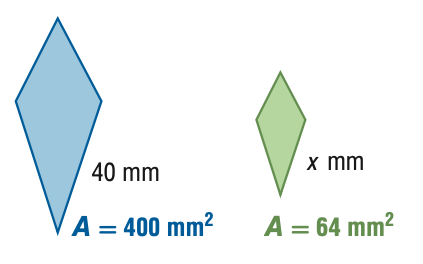Answer the mathemtical geometry problem and directly provide the correct option letter.
Question: For the pair of similar figures, use the given areas to find the scale factor of the blue to the green figure.
Choices: A: \frac { 4 } { 25 } B: \frac { 2 } { 5 } C: \frac { 5 } { 2 } D: \frac { 25 } { 4 } C 